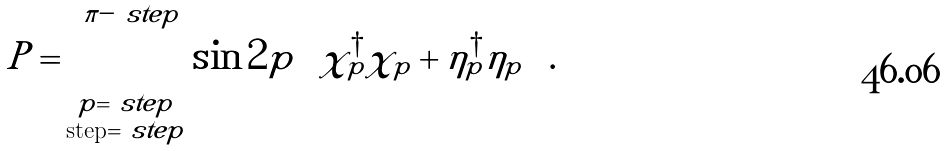<formula> <loc_0><loc_0><loc_500><loc_500>P = \sum _ { \substack { p = \ s t e p \\ \text {step} = \ s t e p } } ^ { \pi - \ s t e p } \sin { 2 p } \left ( \chi ^ { \dagger } _ { p } \chi _ { p } + \eta ^ { \dagger } _ { p } \eta _ { p } \right ) .</formula> 